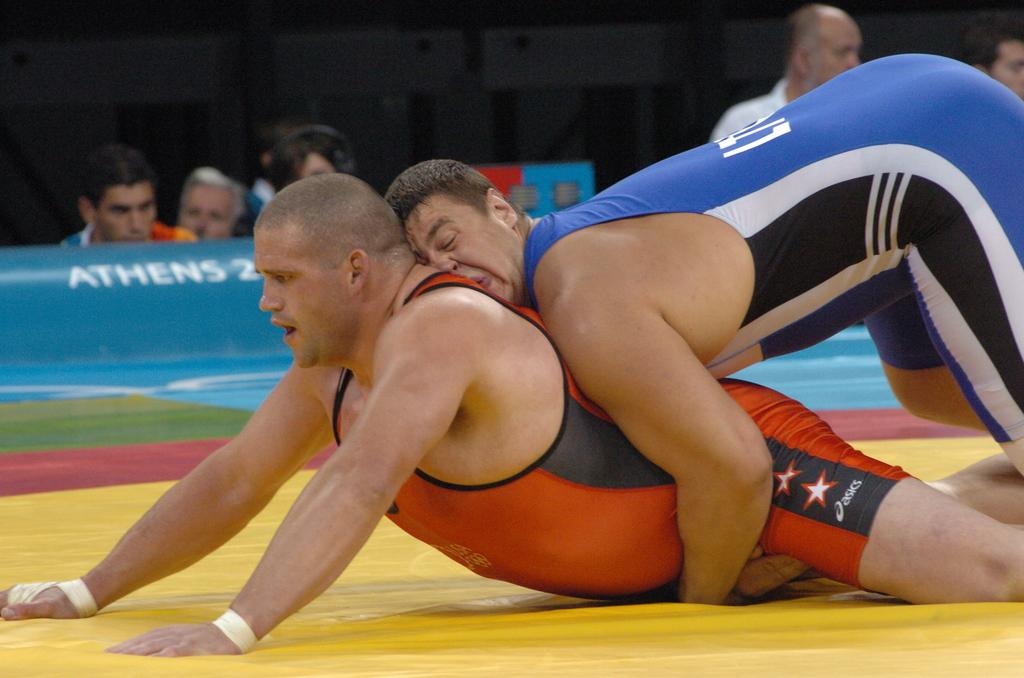<image>
Create a compact narrative representing the image presented. Two men wrestle in front of a blue sign that says Athens on it. 